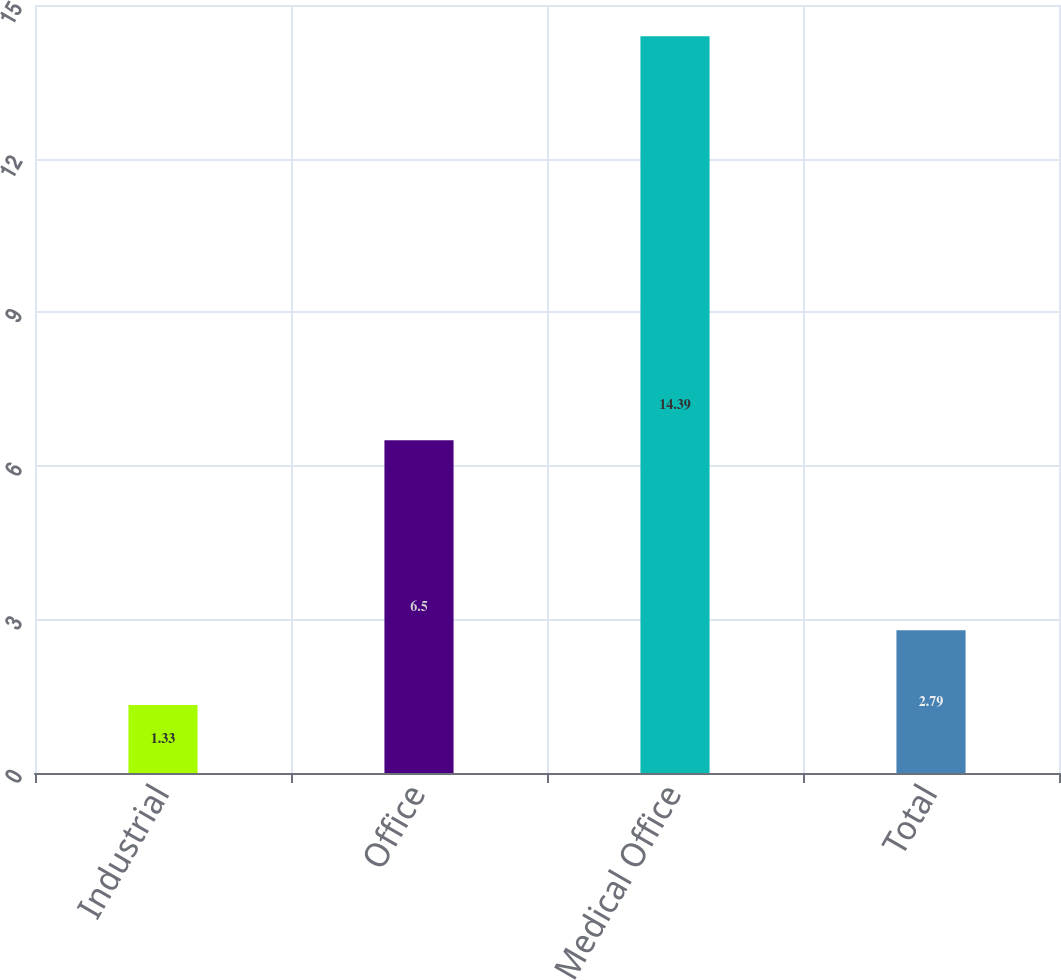Convert chart to OTSL. <chart><loc_0><loc_0><loc_500><loc_500><bar_chart><fcel>Industrial<fcel>Office<fcel>Medical Office<fcel>Total<nl><fcel>1.33<fcel>6.5<fcel>14.39<fcel>2.79<nl></chart> 